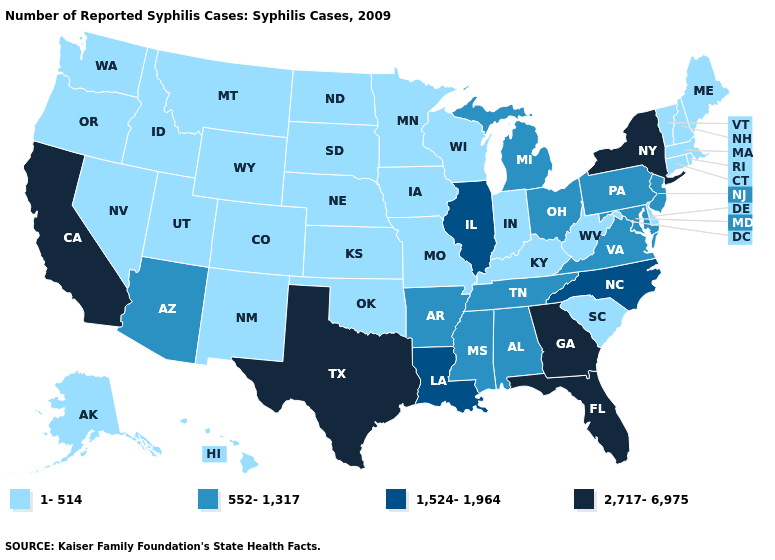What is the value of Idaho?
Give a very brief answer. 1-514. Name the states that have a value in the range 2,717-6,975?
Concise answer only. California, Florida, Georgia, New York, Texas. Does the first symbol in the legend represent the smallest category?
Be succinct. Yes. Does Alabama have the same value as Michigan?
Keep it brief. Yes. Name the states that have a value in the range 1,524-1,964?
Write a very short answer. Illinois, Louisiana, North Carolina. Among the states that border Kentucky , does Missouri have the highest value?
Answer briefly. No. Name the states that have a value in the range 552-1,317?
Short answer required. Alabama, Arizona, Arkansas, Maryland, Michigan, Mississippi, New Jersey, Ohio, Pennsylvania, Tennessee, Virginia. What is the lowest value in states that border Missouri?
Give a very brief answer. 1-514. What is the value of South Dakota?
Give a very brief answer. 1-514. Name the states that have a value in the range 552-1,317?
Be succinct. Alabama, Arizona, Arkansas, Maryland, Michigan, Mississippi, New Jersey, Ohio, Pennsylvania, Tennessee, Virginia. What is the value of New Jersey?
Write a very short answer. 552-1,317. What is the value of Delaware?
Answer briefly. 1-514. Which states have the highest value in the USA?
Short answer required. California, Florida, Georgia, New York, Texas. 